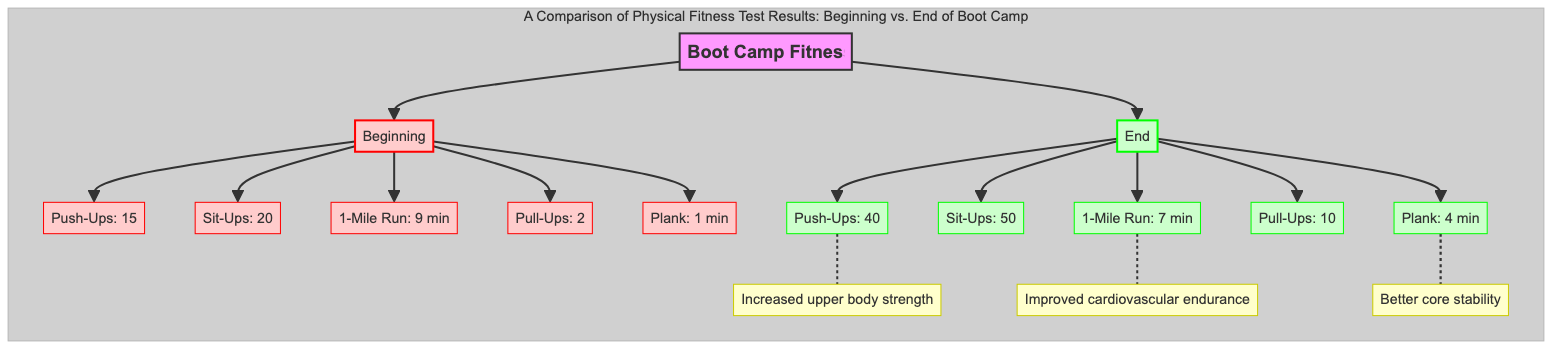What is the number of Push-Ups recorded at the beginning of the boot camp? The diagram indicates the number of Push-Ups at the beginning is represented by the node labeled "Push-Ups: 15", which shows the specific value of 15.
Answer: 15 What is the improvement in Sit-Ups from the beginning to the end of the boot camp? The Sit-Ups at the beginning are noted as 20, and at the end as 50. To find the improvement, subtract 20 from 50, resulting in an increase of 30.
Answer: 30 How many total test categories are compared in this diagram? There are five test categories represented: Push-Ups, Sit-Ups, 1-Mile Run, Pull-Ups, and Plank. Counting these shows a total of 5 categories.
Answer: 5 What does the node related to the 1-Mile Run at the end indicate? At the end of the boot camp, the node states "1-Mile Run: 7 min", which implies the time taken for a 1-mile run after completing the program is 7 minutes.
Answer: 7 min What does the increased number of Pull-Ups suggest about the participant's physical condition? The increase from 2 Pull-Ups at the beginning to 10 at the end suggests a significant improvement in upper body strength, as indicated by the correlation to the node "Increased upper body strength".
Answer: Increased upper body strength What is the total time difference recorded for the Plank exercise from beginning to end? Initially, the Plank time was 1 min, and it increased to 4 min at the end. The total time difference is calculated by subtracting 1 from 4, yielding a difference of 3 minutes.
Answer: 3 min Which physical attribute shows the most improvement according to the data in the diagram? The attribute with the highest increase is Push-Ups, where the number increased from 15 to 40, showing an improvement of 25. Therefore, Push-Ups exhibit the most significant improvement.
Answer: Push-Ups What does the “Improved cardiovascular endurance” label correlate to in the diagram? The label “Improved cardiovascular endurance” is related to the improvement in the 1-Mile Run, which decreased from 9 minutes to 7 minutes. This relationship shows that faster running indicates better cardiovascular health.
Answer: 1-Mile Run What is the value attributed to the Plank exercise at the beginning of the boot camp? The diagram specifies that the Plank duration at the beginning is noted as "Plank: 1 min". This directly provides the initial value as 1 minute.
Answer: 1 min 